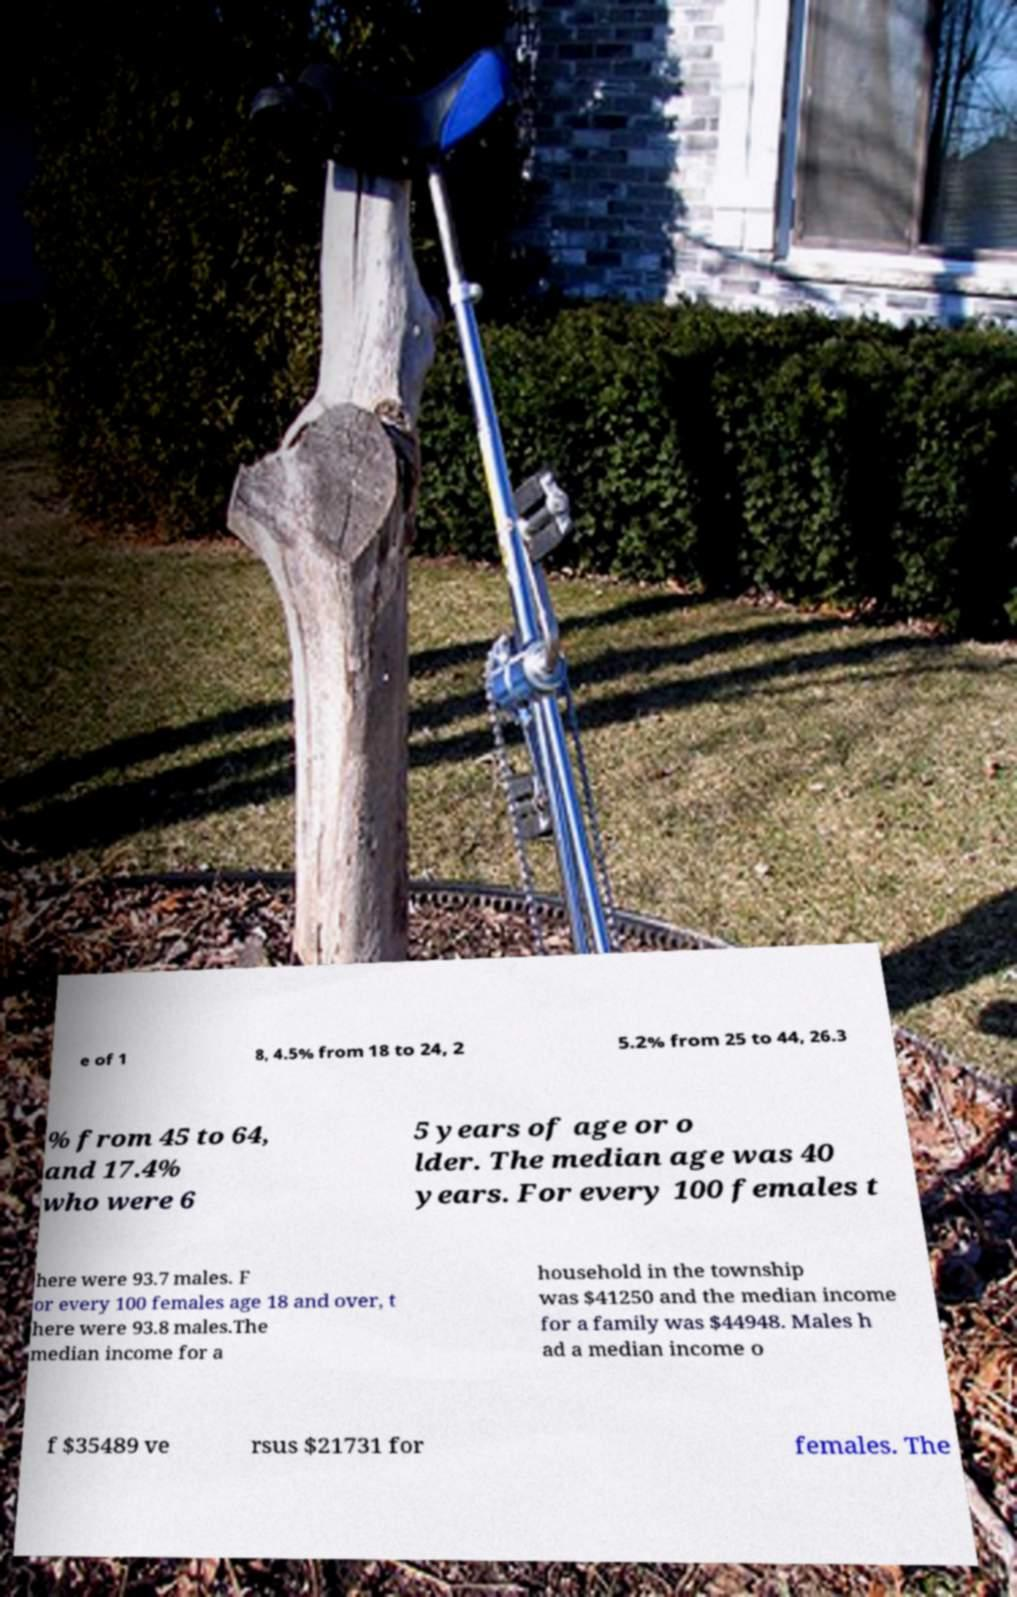Can you read and provide the text displayed in the image?This photo seems to have some interesting text. Can you extract and type it out for me? e of 1 8, 4.5% from 18 to 24, 2 5.2% from 25 to 44, 26.3 % from 45 to 64, and 17.4% who were 6 5 years of age or o lder. The median age was 40 years. For every 100 females t here were 93.7 males. F or every 100 females age 18 and over, t here were 93.8 males.The median income for a household in the township was $41250 and the median income for a family was $44948. Males h ad a median income o f $35489 ve rsus $21731 for females. The 